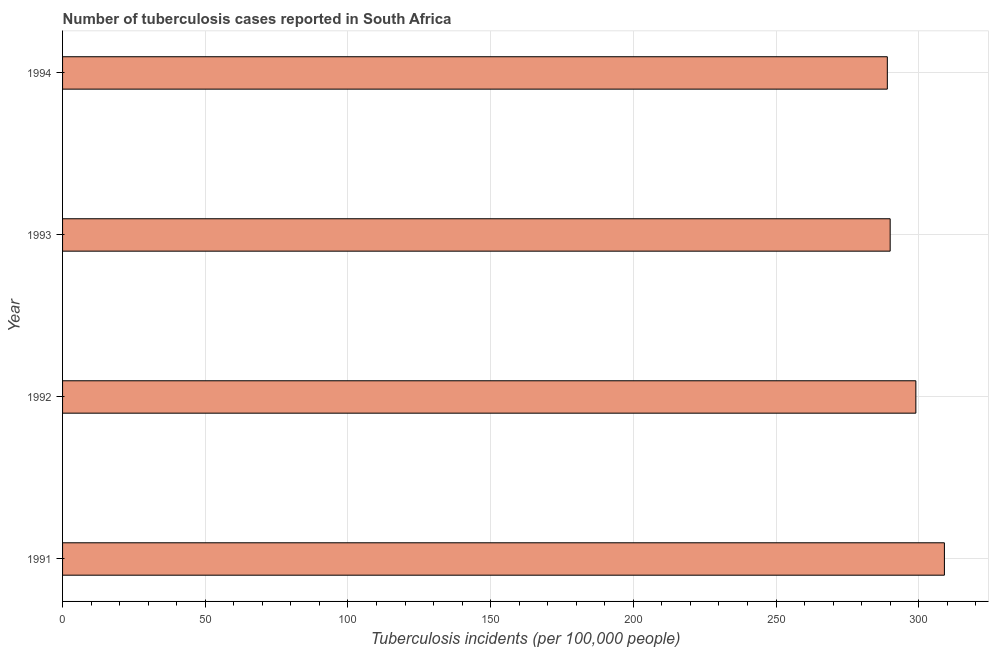What is the title of the graph?
Give a very brief answer. Number of tuberculosis cases reported in South Africa. What is the label or title of the X-axis?
Ensure brevity in your answer.  Tuberculosis incidents (per 100,0 people). What is the label or title of the Y-axis?
Provide a succinct answer. Year. What is the number of tuberculosis incidents in 1993?
Provide a succinct answer. 290. Across all years, what is the maximum number of tuberculosis incidents?
Give a very brief answer. 309. Across all years, what is the minimum number of tuberculosis incidents?
Your answer should be very brief. 289. In which year was the number of tuberculosis incidents maximum?
Provide a succinct answer. 1991. What is the sum of the number of tuberculosis incidents?
Offer a terse response. 1187. What is the average number of tuberculosis incidents per year?
Your answer should be compact. 296. What is the median number of tuberculosis incidents?
Provide a short and direct response. 294.5. In how many years, is the number of tuberculosis incidents greater than 220 ?
Your response must be concise. 4. Do a majority of the years between 1991 and 1992 (inclusive) have number of tuberculosis incidents greater than 10 ?
Your response must be concise. Yes. What is the ratio of the number of tuberculosis incidents in 1992 to that in 1993?
Keep it short and to the point. 1.03. Is the difference between the number of tuberculosis incidents in 1991 and 1994 greater than the difference between any two years?
Ensure brevity in your answer.  Yes. What is the difference between the highest and the second highest number of tuberculosis incidents?
Your response must be concise. 10. Are all the bars in the graph horizontal?
Your answer should be compact. Yes. What is the difference between two consecutive major ticks on the X-axis?
Give a very brief answer. 50. Are the values on the major ticks of X-axis written in scientific E-notation?
Keep it short and to the point. No. What is the Tuberculosis incidents (per 100,000 people) of 1991?
Provide a succinct answer. 309. What is the Tuberculosis incidents (per 100,000 people) in 1992?
Keep it short and to the point. 299. What is the Tuberculosis incidents (per 100,000 people) in 1993?
Ensure brevity in your answer.  290. What is the Tuberculosis incidents (per 100,000 people) of 1994?
Your answer should be compact. 289. What is the difference between the Tuberculosis incidents (per 100,000 people) in 1991 and 1992?
Ensure brevity in your answer.  10. What is the difference between the Tuberculosis incidents (per 100,000 people) in 1991 and 1994?
Give a very brief answer. 20. What is the difference between the Tuberculosis incidents (per 100,000 people) in 1992 and 1993?
Keep it short and to the point. 9. What is the ratio of the Tuberculosis incidents (per 100,000 people) in 1991 to that in 1992?
Give a very brief answer. 1.03. What is the ratio of the Tuberculosis incidents (per 100,000 people) in 1991 to that in 1993?
Your response must be concise. 1.07. What is the ratio of the Tuberculosis incidents (per 100,000 people) in 1991 to that in 1994?
Your response must be concise. 1.07. What is the ratio of the Tuberculosis incidents (per 100,000 people) in 1992 to that in 1993?
Offer a terse response. 1.03. What is the ratio of the Tuberculosis incidents (per 100,000 people) in 1992 to that in 1994?
Keep it short and to the point. 1.03. What is the ratio of the Tuberculosis incidents (per 100,000 people) in 1993 to that in 1994?
Make the answer very short. 1. 